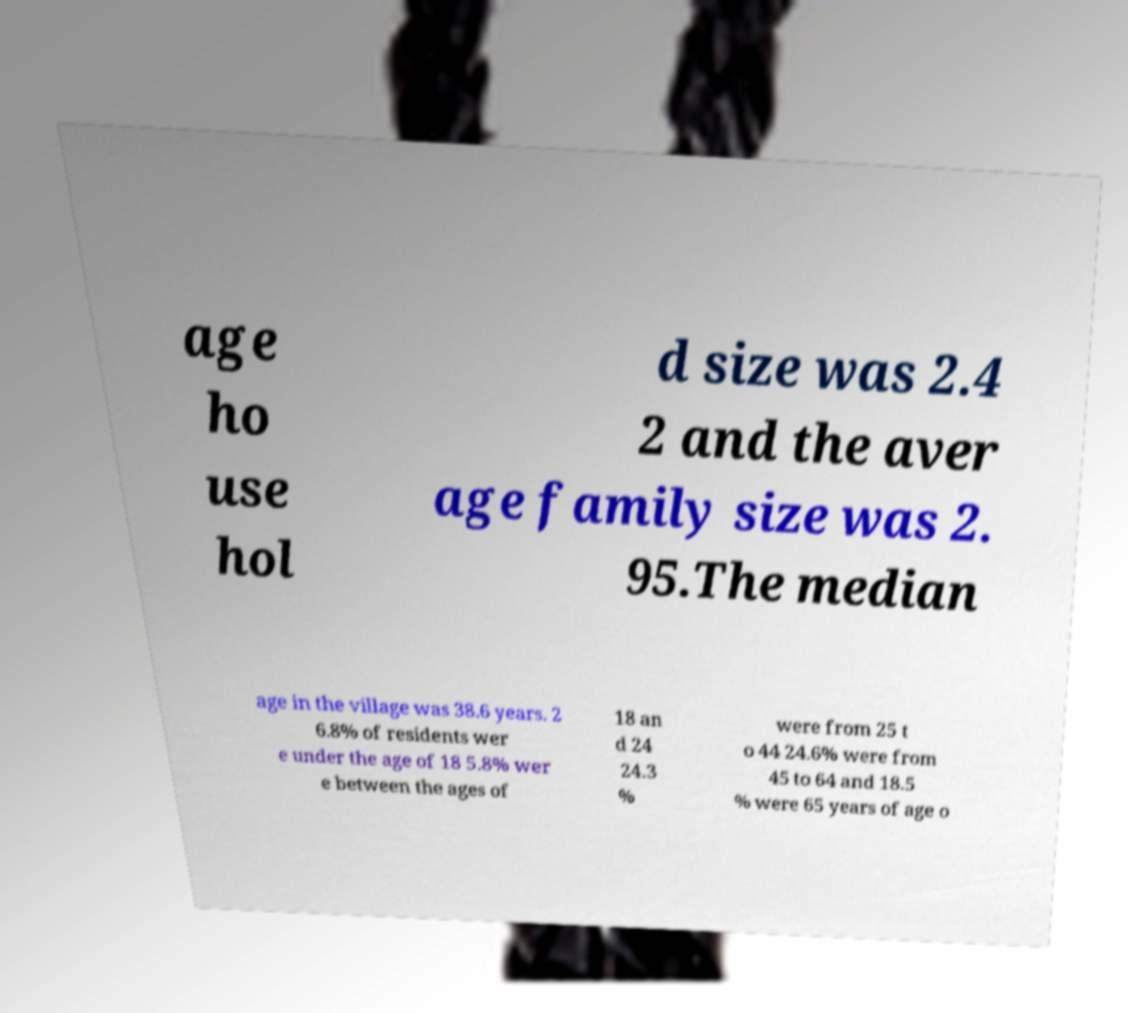Can you read and provide the text displayed in the image?This photo seems to have some interesting text. Can you extract and type it out for me? age ho use hol d size was 2.4 2 and the aver age family size was 2. 95.The median age in the village was 38.6 years. 2 6.8% of residents wer e under the age of 18 5.8% wer e between the ages of 18 an d 24 24.3 % were from 25 t o 44 24.6% were from 45 to 64 and 18.5 % were 65 years of age o 